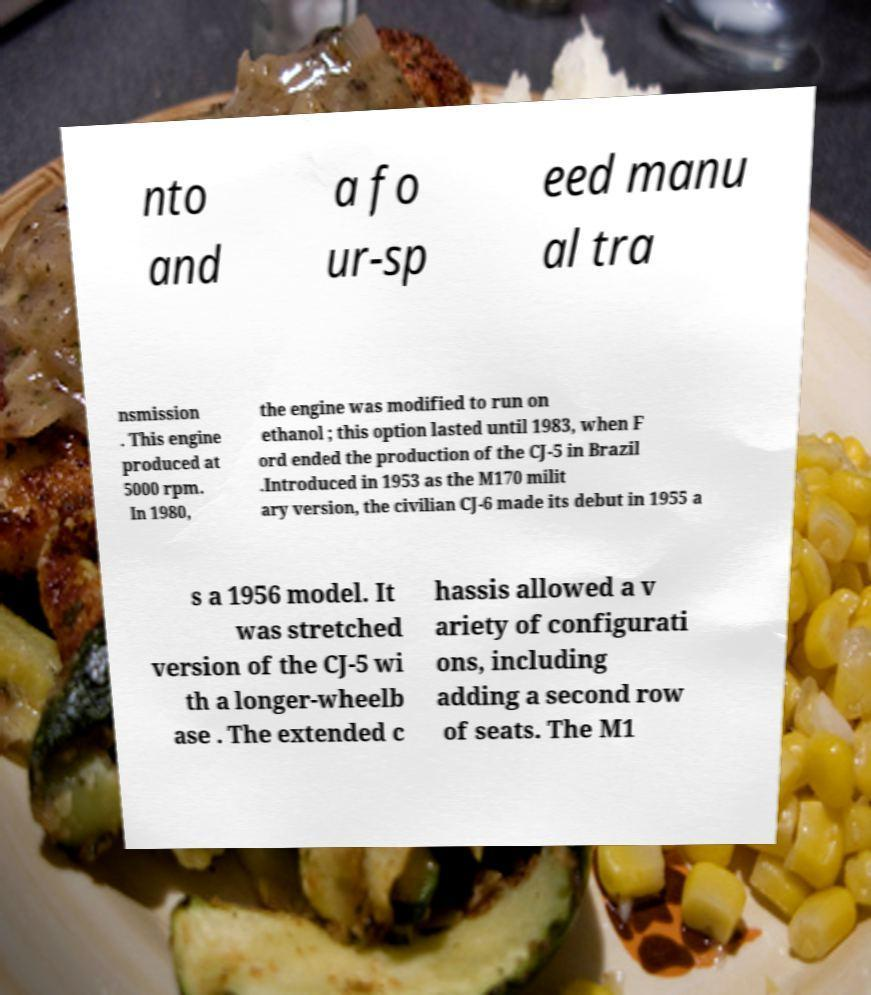What messages or text are displayed in this image? I need them in a readable, typed format. nto and a fo ur-sp eed manu al tra nsmission . This engine produced at 5000 rpm. In 1980, the engine was modified to run on ethanol ; this option lasted until 1983, when F ord ended the production of the CJ-5 in Brazil .Introduced in 1953 as the M170 milit ary version, the civilian CJ-6 made its debut in 1955 a s a 1956 model. It was stretched version of the CJ-5 wi th a longer-wheelb ase . The extended c hassis allowed a v ariety of configurati ons, including adding a second row of seats. The M1 